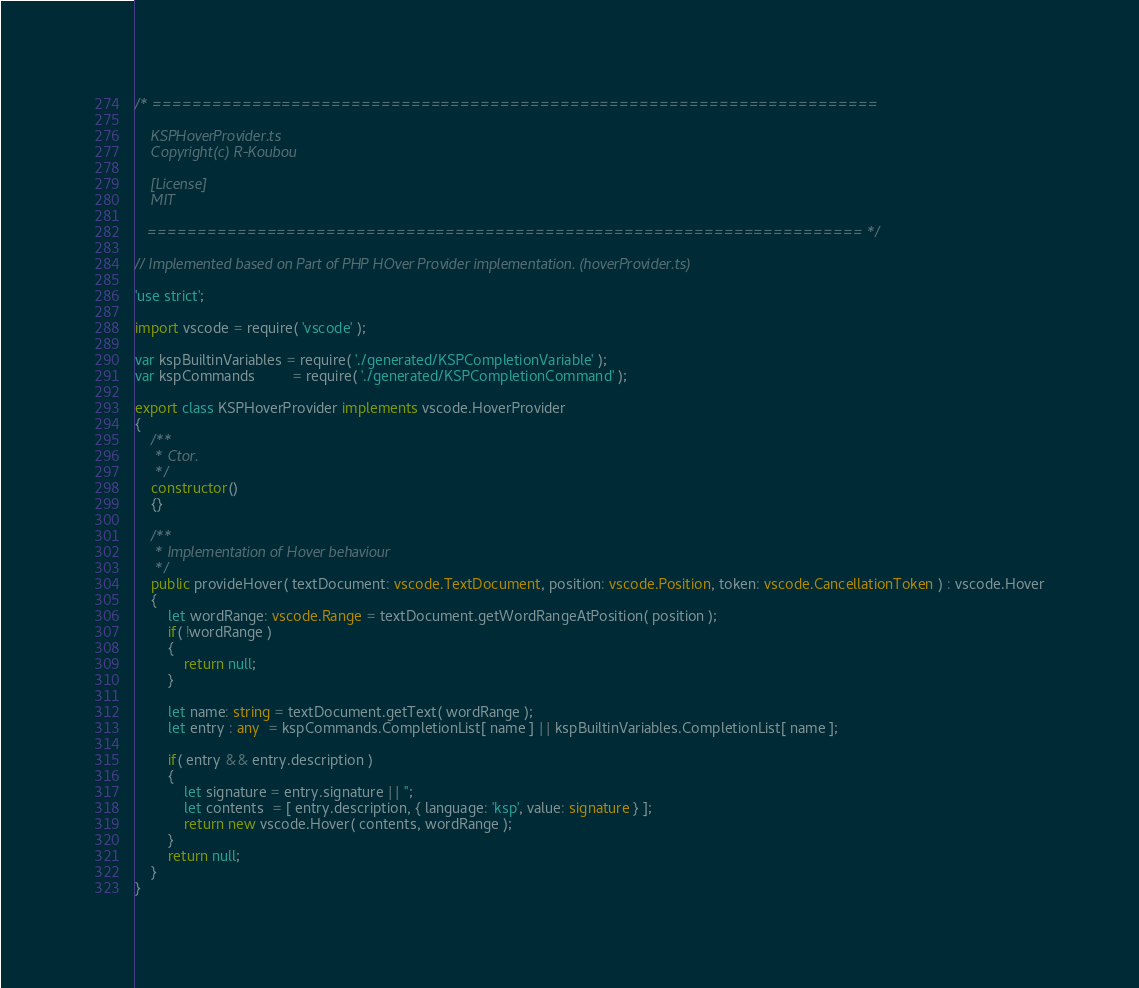<code> <loc_0><loc_0><loc_500><loc_500><_TypeScript_>/* =========================================================================

    KSPHoverProvider.ts
    Copyright(c) R-Koubou

    [License]
    MIT

   ======================================================================== */

// Implemented based on Part of PHP HOver Provider implementation. (hoverProvider.ts)

'use strict';

import vscode = require( 'vscode' );

var kspBuiltinVariables = require( './generated/KSPCompletionVariable' );
var kspCommands         = require( './generated/KSPCompletionCommand' );

export class KSPHoverProvider implements vscode.HoverProvider
{
    /**
     * Ctor.
     */
    constructor()
    {}

    /**
     * Implementation of Hover behaviour
     */
    public provideHover( textDocument: vscode.TextDocument, position: vscode.Position, token: vscode.CancellationToken ) : vscode.Hover
    {
        let wordRange: vscode.Range = textDocument.getWordRangeAtPosition( position );
        if( !wordRange )
        {
            return null;
        }

        let name: string = textDocument.getText( wordRange );
        let entry : any  = kspCommands.CompletionList[ name ] || kspBuiltinVariables.CompletionList[ name ];

        if( entry && entry.description )
        {
            let signature = entry.signature || '';
            let contents  = [ entry.description, { language: 'ksp', value: signature } ];
            return new vscode.Hover( contents, wordRange );
        }
        return null;
    }
}
</code> 